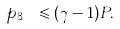Convert formula to latex. <formula><loc_0><loc_0><loc_500><loc_500>p _ { 3 _ { \ } } \leqslant ( \gamma - 1 ) P .</formula> 